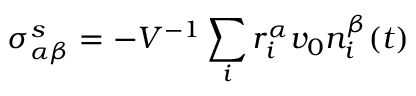<formula> <loc_0><loc_0><loc_500><loc_500>\sigma _ { \alpha \beta } ^ { s } = - V ^ { - 1 } \sum _ { i } r _ { i } ^ { \alpha } v _ { 0 } n _ { i } ^ { \beta } ( t )</formula> 